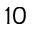<formula> <loc_0><loc_0><loc_500><loc_500>1 0</formula> 